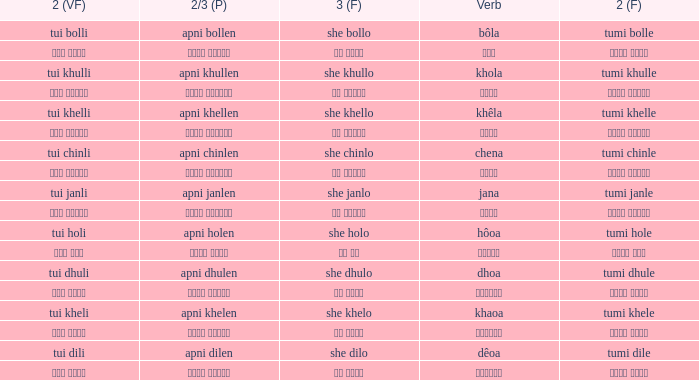Can you parse all the data within this table? {'header': ['2 (VF)', '2/3 (P)', '3 (F)', 'Verb', '2 (F)'], 'rows': [['tui bolli', 'apni bollen', 'she bollo', 'bôla', 'tumi bolle'], ['তুই বললি', 'আপনি বললেন', 'সে বললো', 'বলা', 'তুমি বললে'], ['tui khulli', 'apni khullen', 'she khullo', 'khola', 'tumi khulle'], ['তুই খুললি', 'আপনি খুললেন', 'সে খুললো', 'খোলা', 'তুমি খুললে'], ['tui khelli', 'apni khellen', 'she khello', 'khêla', 'tumi khelle'], ['তুই খেললি', 'আপনি খেললেন', 'সে খেললো', 'খেলে', 'তুমি খেললে'], ['tui chinli', 'apni chinlen', 'she chinlo', 'chena', 'tumi chinle'], ['তুই চিনলি', 'আপনি চিনলেন', 'সে চিনলো', 'চেনা', 'তুমি চিনলে'], ['tui janli', 'apni janlen', 'she janlo', 'jana', 'tumi janle'], ['তুই জানলি', 'আপনি জানলেন', 'সে জানলে', 'জানা', 'তুমি জানলে'], ['tui holi', 'apni holen', 'she holo', 'hôoa', 'tumi hole'], ['তুই হলি', 'আপনি হলেন', 'সে হল', 'হওয়া', 'তুমি হলে'], ['tui dhuli', 'apni dhulen', 'she dhulo', 'dhoa', 'tumi dhule'], ['তুই ধুলি', 'আপনি ধুলেন', 'সে ধুলো', 'ধোওয়া', 'তুমি ধুলে'], ['tui kheli', 'apni khelen', 'she khelo', 'khaoa', 'tumi khele'], ['তুই খেলি', 'আপনি খেলেন', 'সে খেলো', 'খাওয়া', 'তুমি খেলে'], ['tui dili', 'apni dilen', 'she dilo', 'dêoa', 'tumi dile'], ['তুই দিলি', 'আপনি দিলেন', 'সে দিলো', 'দেওয়া', 'তুমি দিলে']]} What is the 2(vf) for তুমি বললে? তুই বললি. 